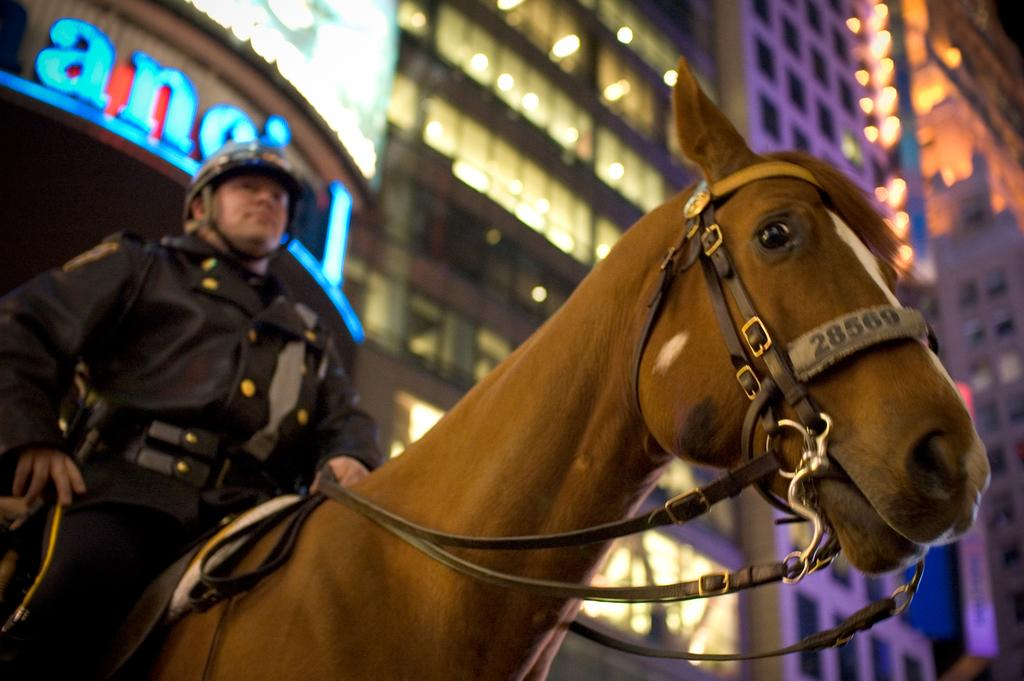What type of scene is depicted in the image? The image is of an outdoor scene. What is the main subject in the center of the image? There is a horse in the center of the image. Who is on the horse, and what is he wearing? A man is sitting on the horse, and he is wearing a helmet. What can be seen in the background of the image? There are buildings and lights visible in the background. How does the maid interact with the tin in the image? There is no maid or tin present in the image. Is there a fight happening between the man and the horse in the image? No, there is no fight depicted in the image; the man is simply sitting on the horse. 